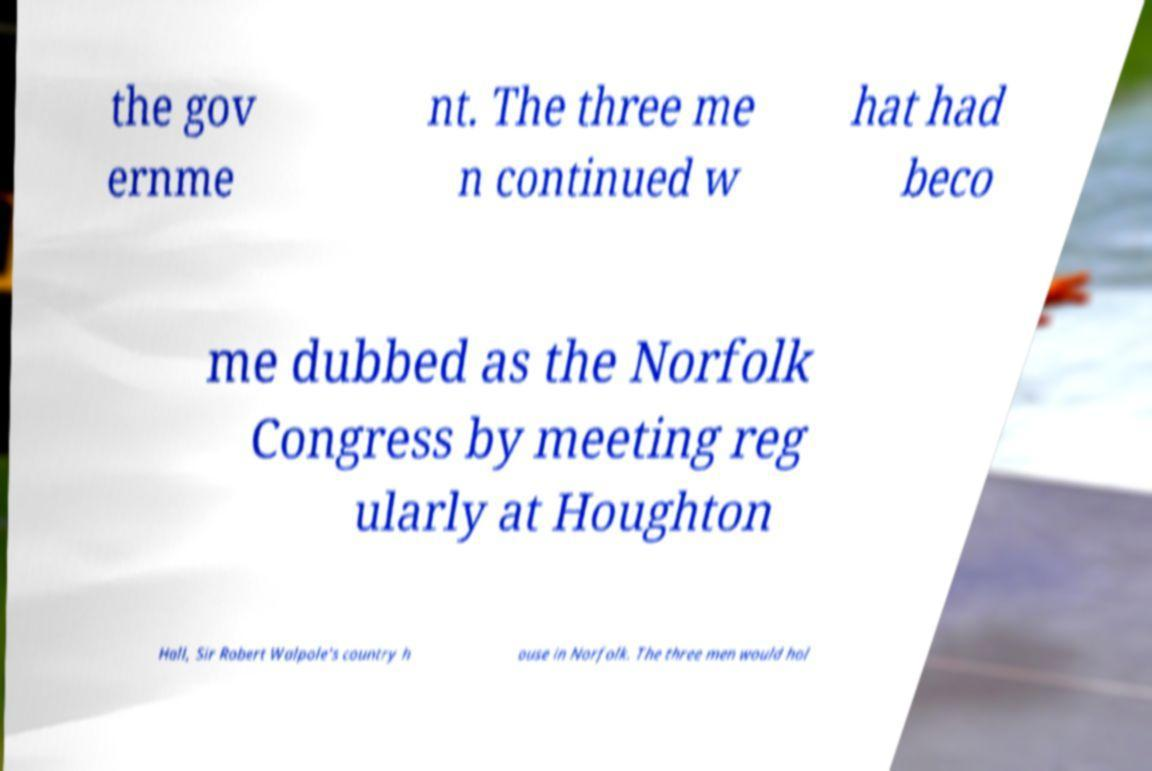Could you assist in decoding the text presented in this image and type it out clearly? the gov ernme nt. The three me n continued w hat had beco me dubbed as the Norfolk Congress by meeting reg ularly at Houghton Hall, Sir Robert Walpole's country h ouse in Norfolk. The three men would hol 